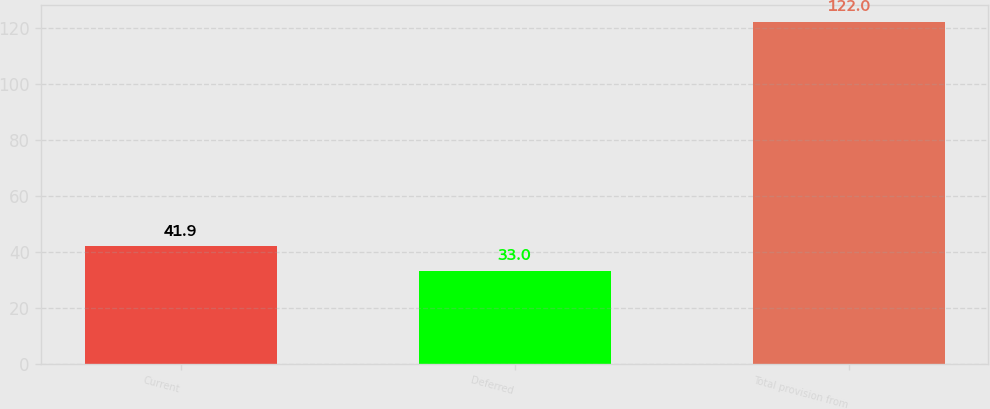Convert chart. <chart><loc_0><loc_0><loc_500><loc_500><bar_chart><fcel>Current<fcel>Deferred<fcel>Total provision from<nl><fcel>41.9<fcel>33<fcel>122<nl></chart> 